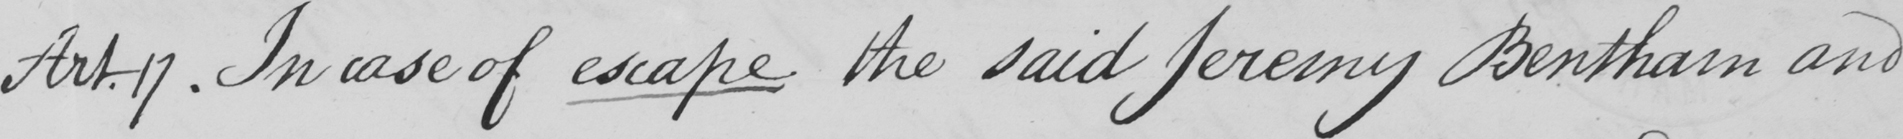Please provide the text content of this handwritten line. Art . 17 . in case of escape the said Jeremy Bentham and 